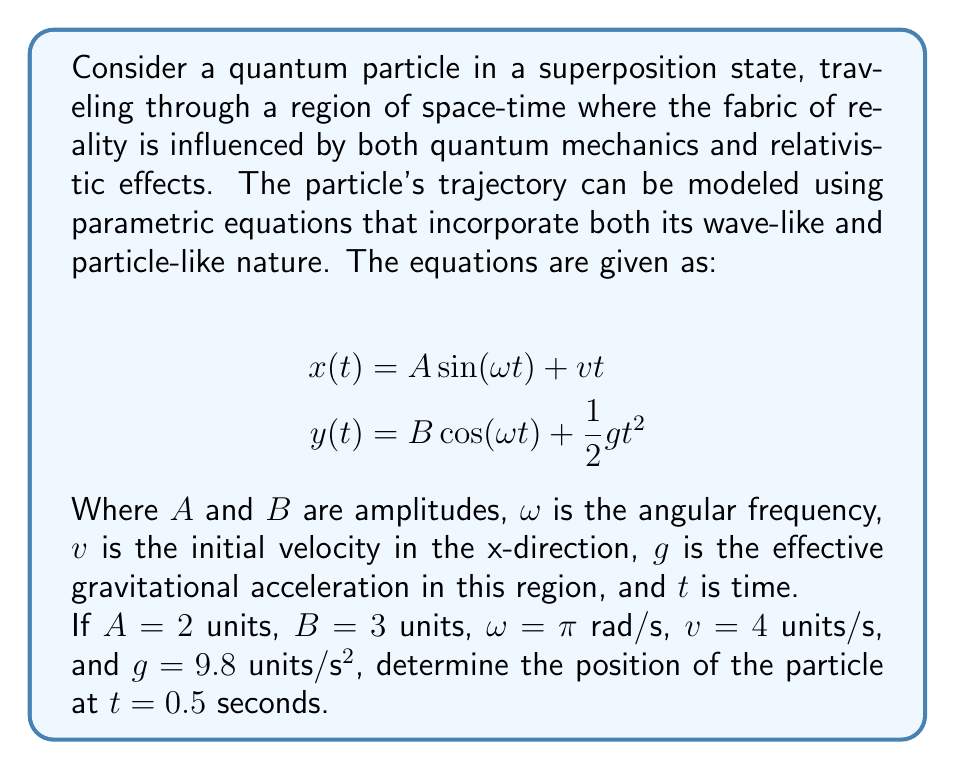Show me your answer to this math problem. To solve this problem, we need to follow these steps:

1) We have the parametric equations:
   $$x(t) = A \sin(\omega t) + vt$$
   $$y(t) = B \cos(\omega t) + \frac{1}{2}gt^2$$

2) We're given the following values:
   $A = 2$ units
   $B = 3$ units
   $\omega = \pi$ rad/s
   $v = 4$ units/s
   $g = 9.8$ units/s²
   $t = 0.5$ seconds

3) Let's calculate $x(0.5)$ first:
   $$x(0.5) = 2 \sin(\pi \cdot 0.5) + 4 \cdot 0.5$$
   $$= 2 \sin(\frac{\pi}{2}) + 2$$
   $$= 2 \cdot 1 + 2 = 4$$

4) Now let's calculate $y(0.5)$:
   $$y(0.5) = 3 \cos(\pi \cdot 0.5) + \frac{1}{2} \cdot 9.8 \cdot 0.5^2$$
   $$= 3 \cos(\frac{\pi}{2}) + \frac{1}{2} \cdot 9.8 \cdot 0.25$$
   $$= 3 \cdot 0 + 4.9 \cdot 0.25 = 1.225$$

5) Therefore, at $t = 0.5$ seconds, the position of the particle is $(4, 1.225)$ units.

This result demonstrates how the particle's position is influenced by both its wave-like nature (represented by the sinusoidal terms) and its particle-like nature (represented by the linear and quadratic terms), creating a trajectory that seems to defy classical physics but can be explained through quantum mechanics and relativity.
Answer: The position of the quantum particle at $t = 0.5$ seconds is $(4, 1.225)$ units. 